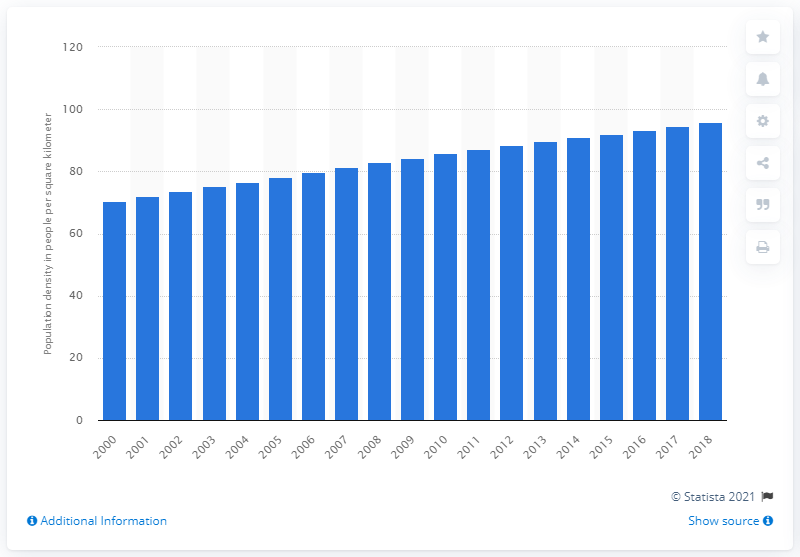List a handful of essential elements in this visual. In 2018, the population density of Malaysia was 95.96 people per square kilometer. 